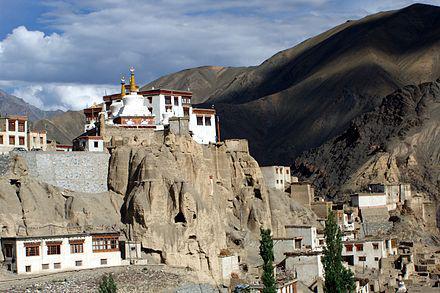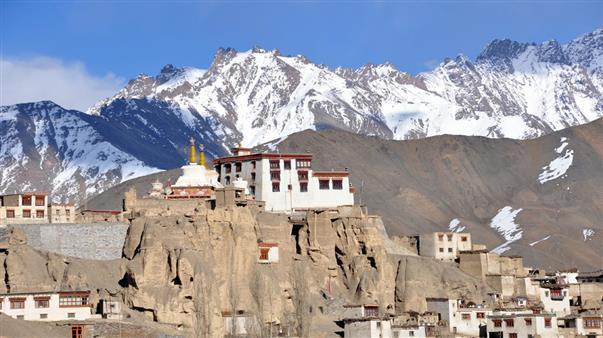The first image is the image on the left, the second image is the image on the right. Examine the images to the left and right. Is the description "A statue of a seated human figure is visible amid flat-roofed buildings." accurate? Answer yes or no. No. 